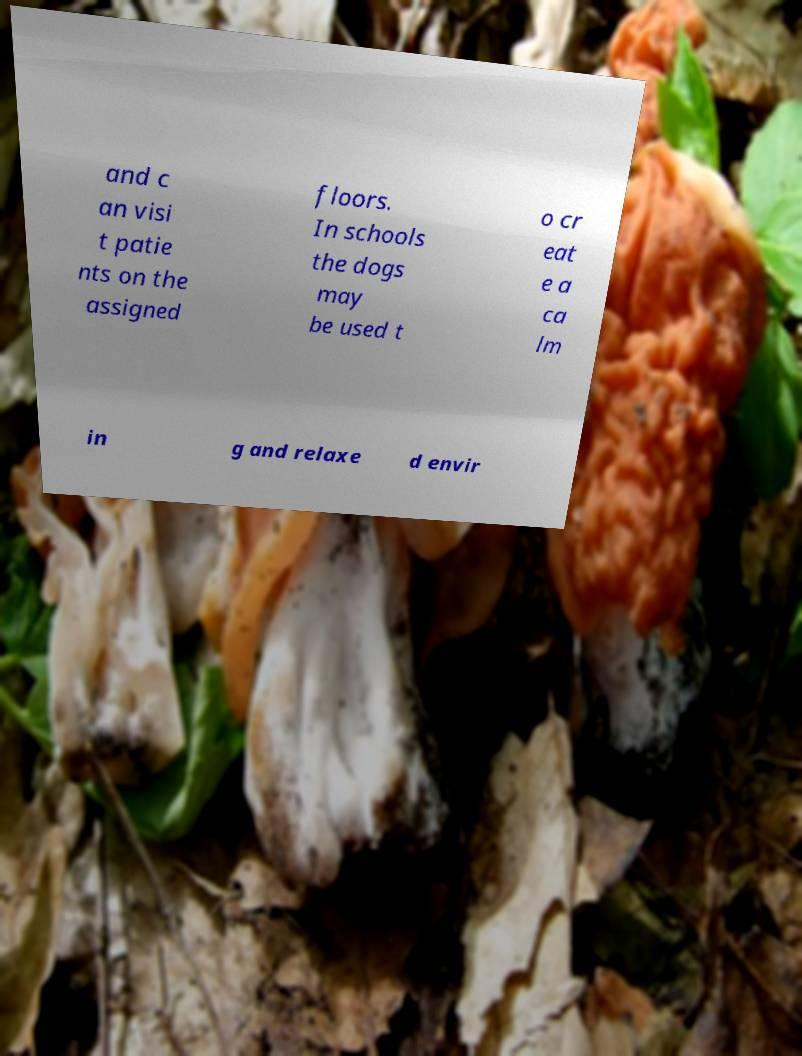For documentation purposes, I need the text within this image transcribed. Could you provide that? and c an visi t patie nts on the assigned floors. In schools the dogs may be used t o cr eat e a ca lm in g and relaxe d envir 